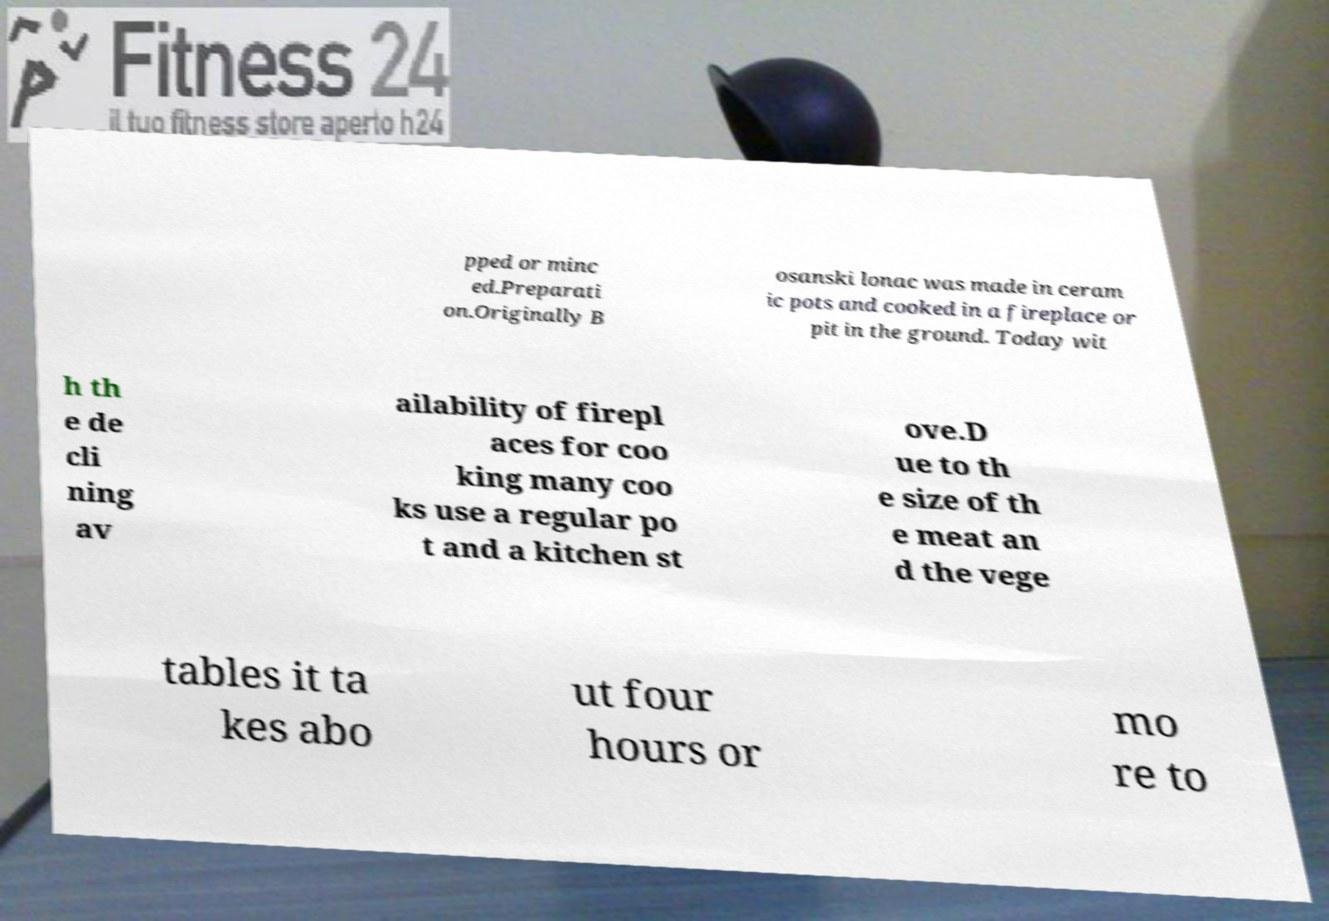What messages or text are displayed in this image? I need them in a readable, typed format. pped or minc ed.Preparati on.Originally B osanski lonac was made in ceram ic pots and cooked in a fireplace or pit in the ground. Today wit h th e de cli ning av ailability of firepl aces for coo king many coo ks use a regular po t and a kitchen st ove.D ue to th e size of th e meat an d the vege tables it ta kes abo ut four hours or mo re to 